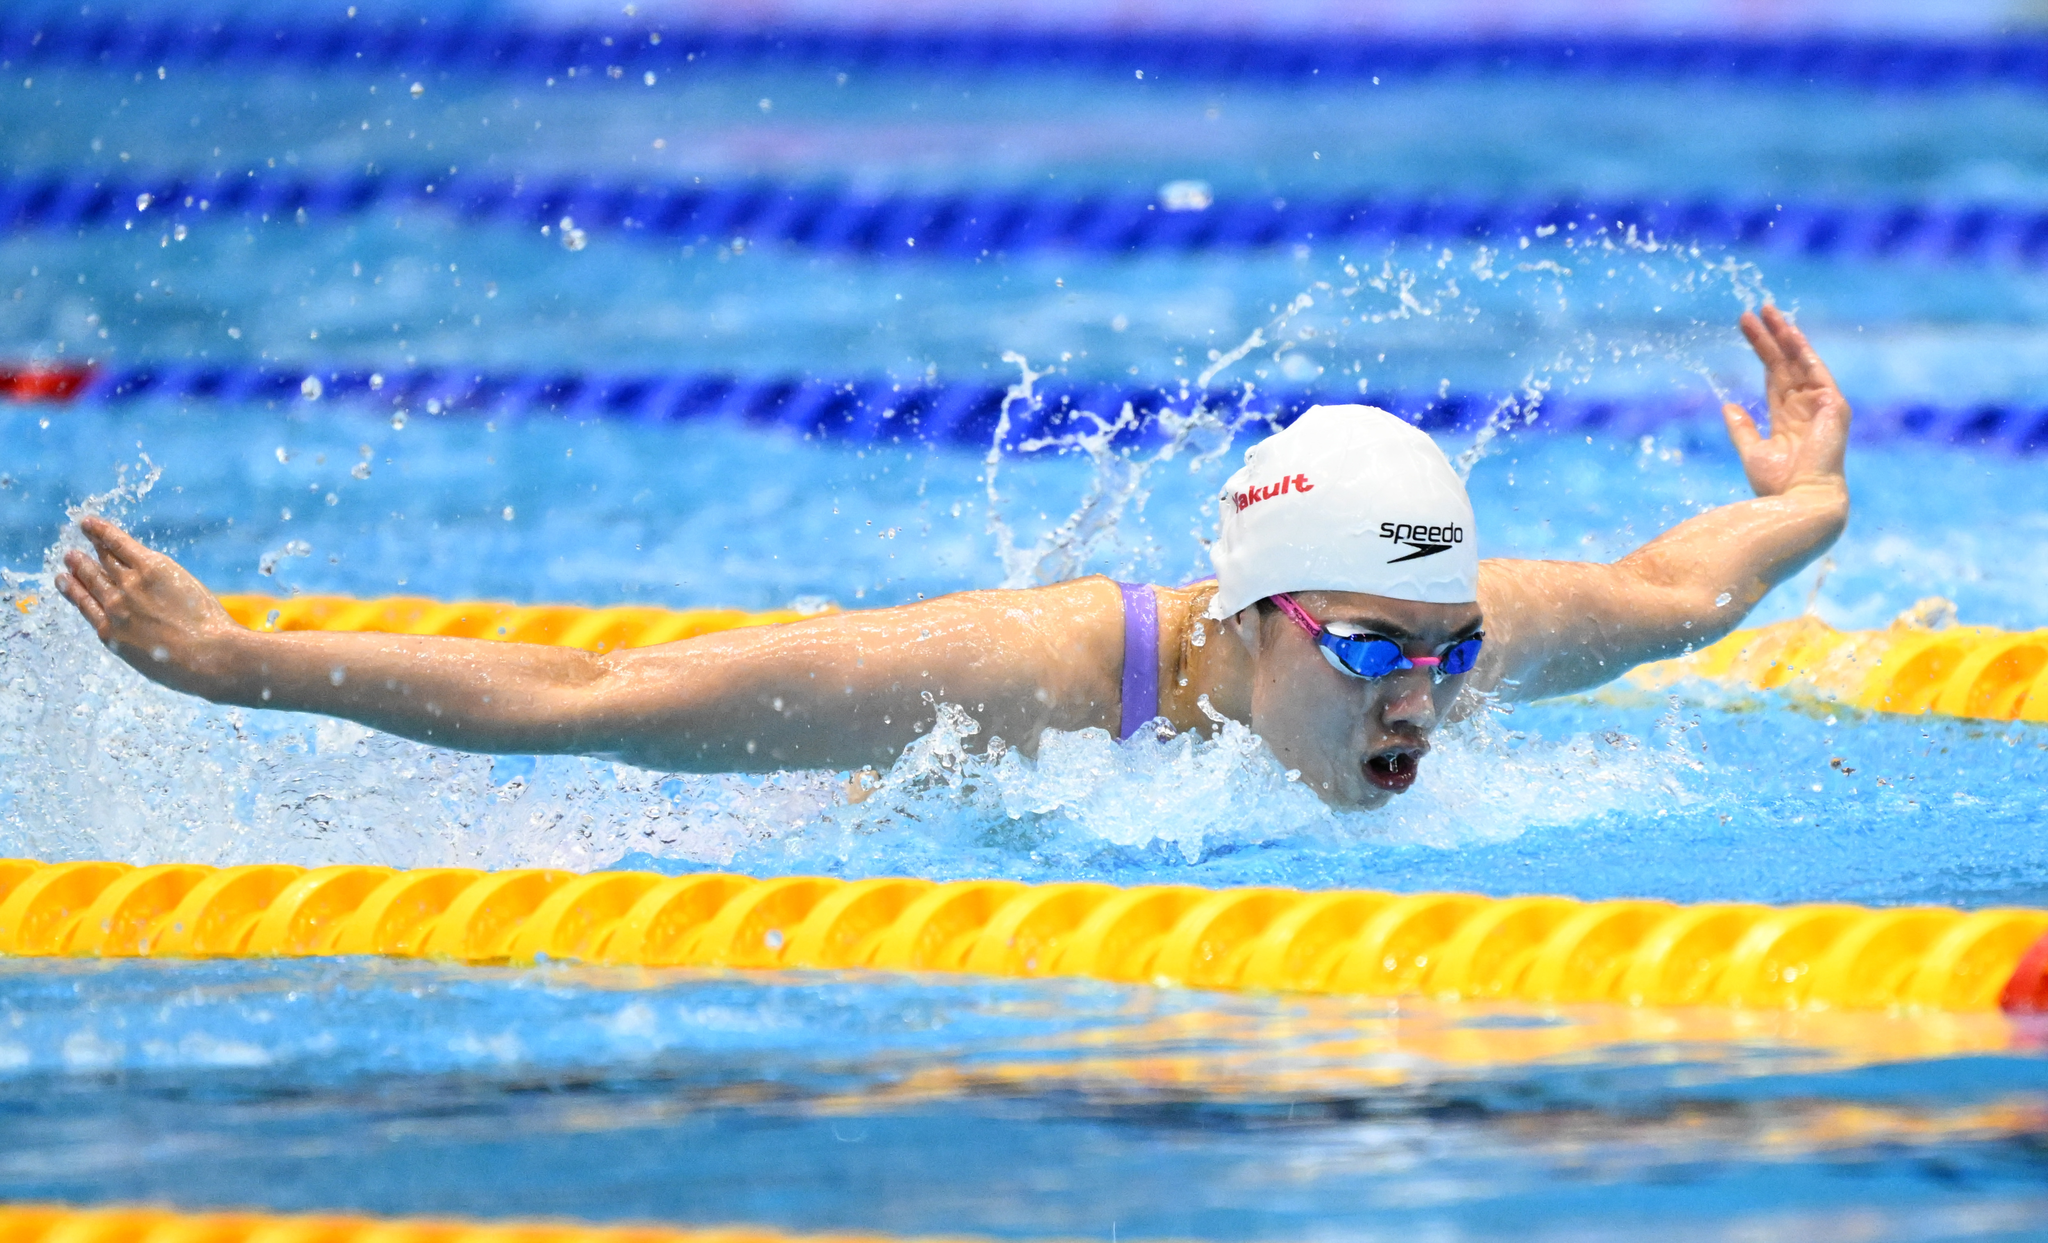What swimming style is being depicted? The swimming style being depicted in the image is the butterfly stroke. This style is characterized by the simultaneous overhead movement of the arms combined with a dolphin-like kick. The swimmer's arms are both moving in a circular pattern, and you can also see the characteristic wave-like body movement that is part of the butterfly technique. 